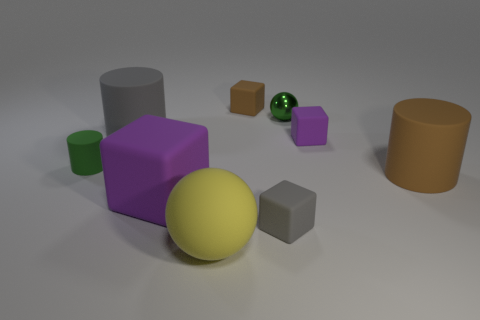Are there any other things of the same color as the big ball?
Offer a terse response. No. What size is the yellow object that is the same material as the tiny gray block?
Provide a short and direct response. Large. Do the yellow ball and the green shiny object have the same size?
Offer a very short reply. No. Are there any big metal things?
Provide a succinct answer. No. There is a purple object that is in front of the big thing that is right of the small purple cube on the right side of the large yellow object; what is its size?
Ensure brevity in your answer.  Large. How many other things are the same material as the large yellow object?
Your answer should be compact. 7. What number of green matte cylinders have the same size as the gray cylinder?
Offer a very short reply. 0. What is the tiny object that is on the left side of the rubber cube that is left of the block that is behind the shiny ball made of?
Offer a very short reply. Rubber. How many objects are purple metal blocks or green cylinders?
Your answer should be compact. 1. Is there any other thing that is the same material as the small ball?
Provide a short and direct response. No. 